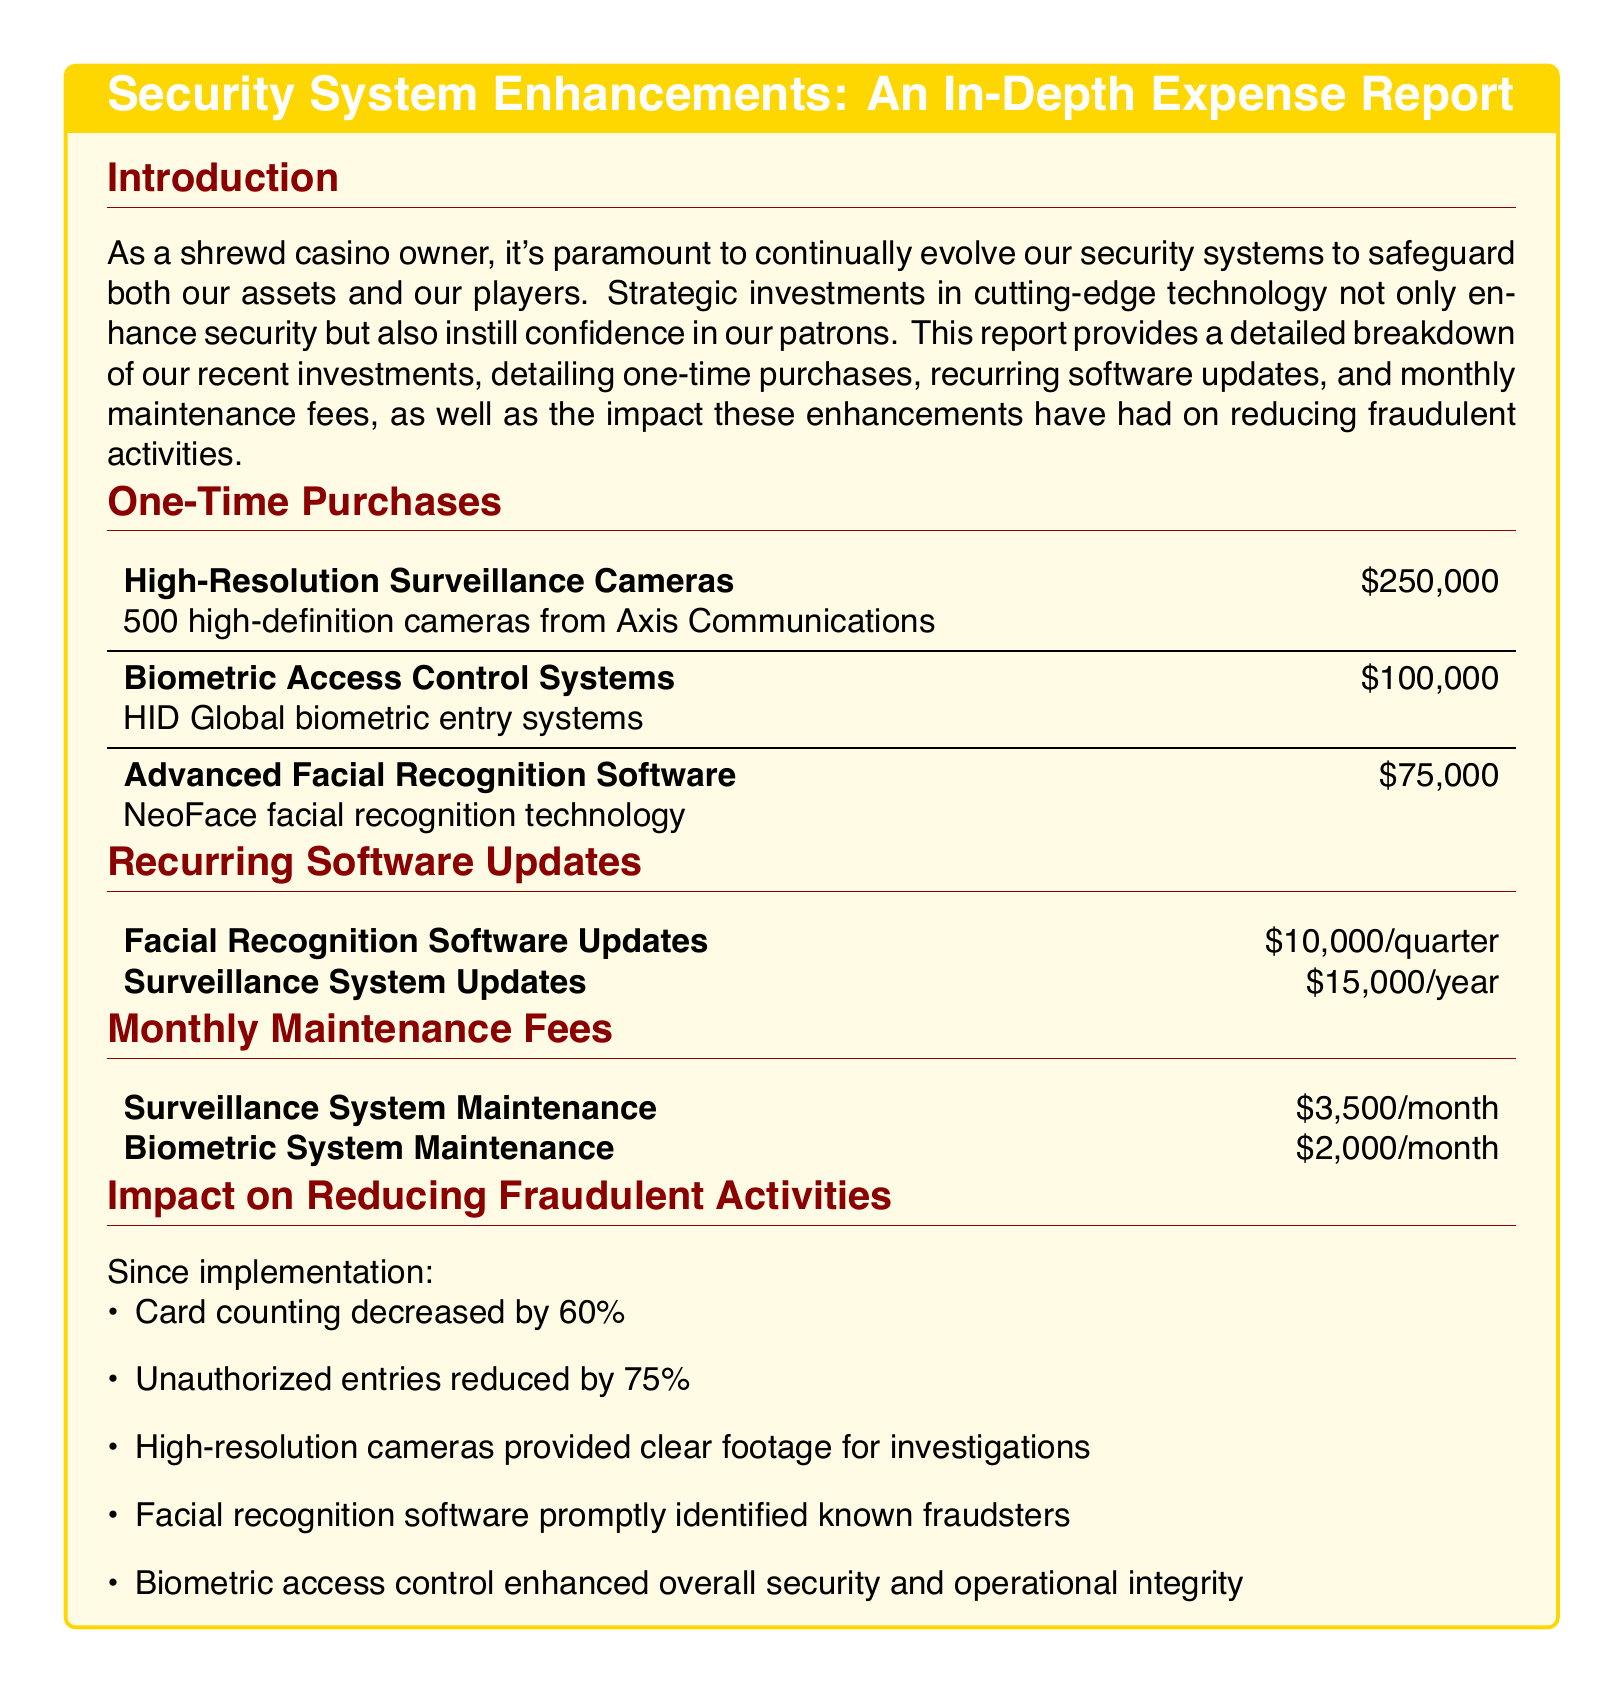What is the total cost of high-resolution surveillance cameras? The total cost is stated as a one-time purchase for the cameras, which is $250,000.
Answer: $250,000 What is the cost for facial recognition software updates? The document mentions that facial recognition software updates cost $10,000 per quarter.
Answer: $10,000/quarter How much are the monthly maintenance fees for the biometric system? The document specifies that the maintenance fee for the biometric system is $2,000 per month.
Answer: $2,000/month What percentage did card counting decrease by after the system enhancements? The report indicates that card counting decreased by 60 percent after the implementations.
Answer: 60% How many high-definition cameras were purchased? The document lists that 500 high-definition cameras were acquired.
Answer: 500 What is the total amount spent on one-time purchases? The total of one-time purchases is calculated by summing the amounts of high-resolution cameras, biometric controls, and facial recognition software, which is $250,000 + $100,000 + $75,000 = $425,000.
Answer: $425,000 What technology did the facial recognition software use? The report states that NeoFace facial recognition technology was the chosen solution.
Answer: NeoFace What is the annual cost for surveillance system updates? The document indicates that the cost for surveillance system updates is $15,000 per year.
Answer: $15,000/year How much did unauthorized entries reduce after enhancements? The document notes that unauthorized entries reduced by 75 percent due to the enhancements made.
Answer: 75% 